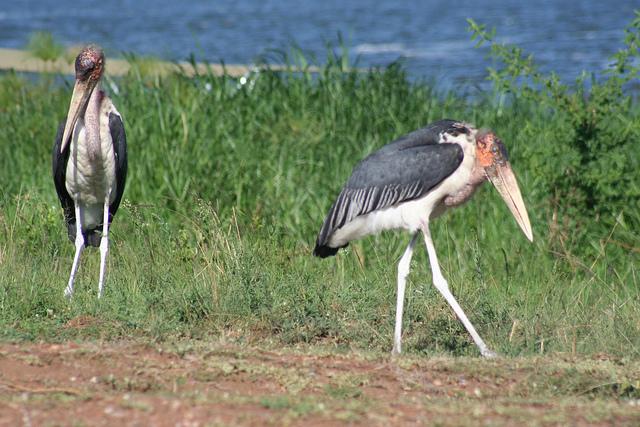Is that a lake of a river in the background?
Keep it brief. Lake. What color is the birds chest?
Quick response, please. White. What kind of birds are these?
Short answer required. Seagulls. 